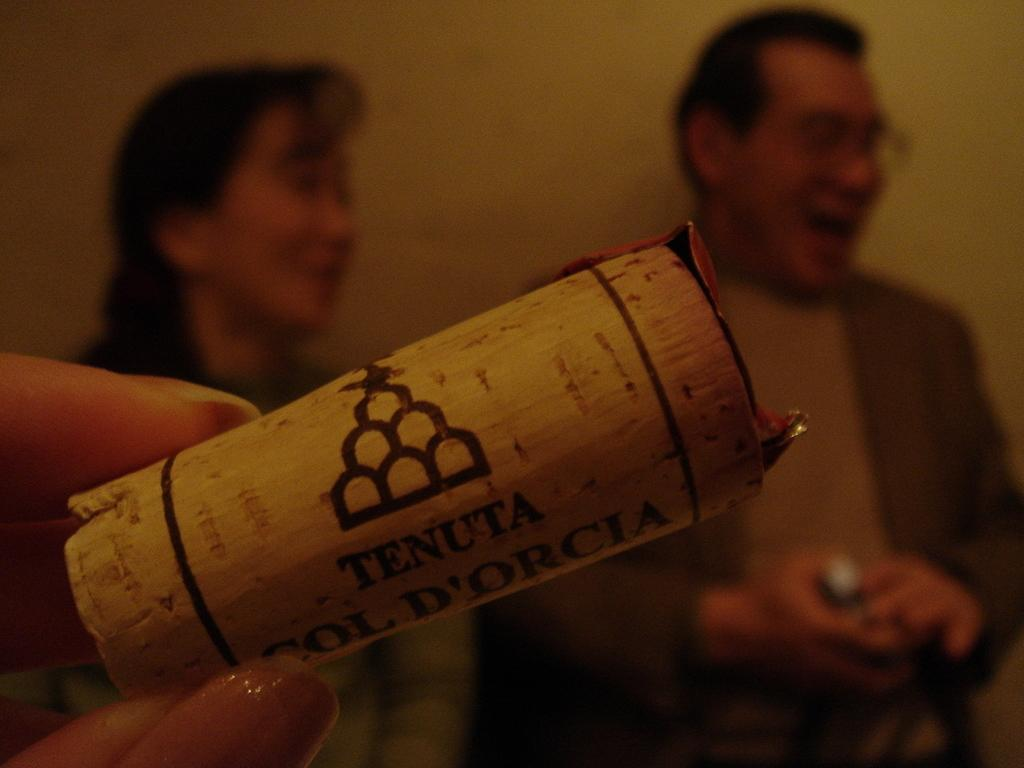What is the main subject in the center of the image? There is a paper with text in the center of the image. What can be observed about the people in the background? There are persons smiling in the background. Where is a hand of a person visible in the image? A hand of a person is visible on the left side of the image. What type of vegetable is being washed in the sink in the image? There is no sink or vegetable present in the image. 